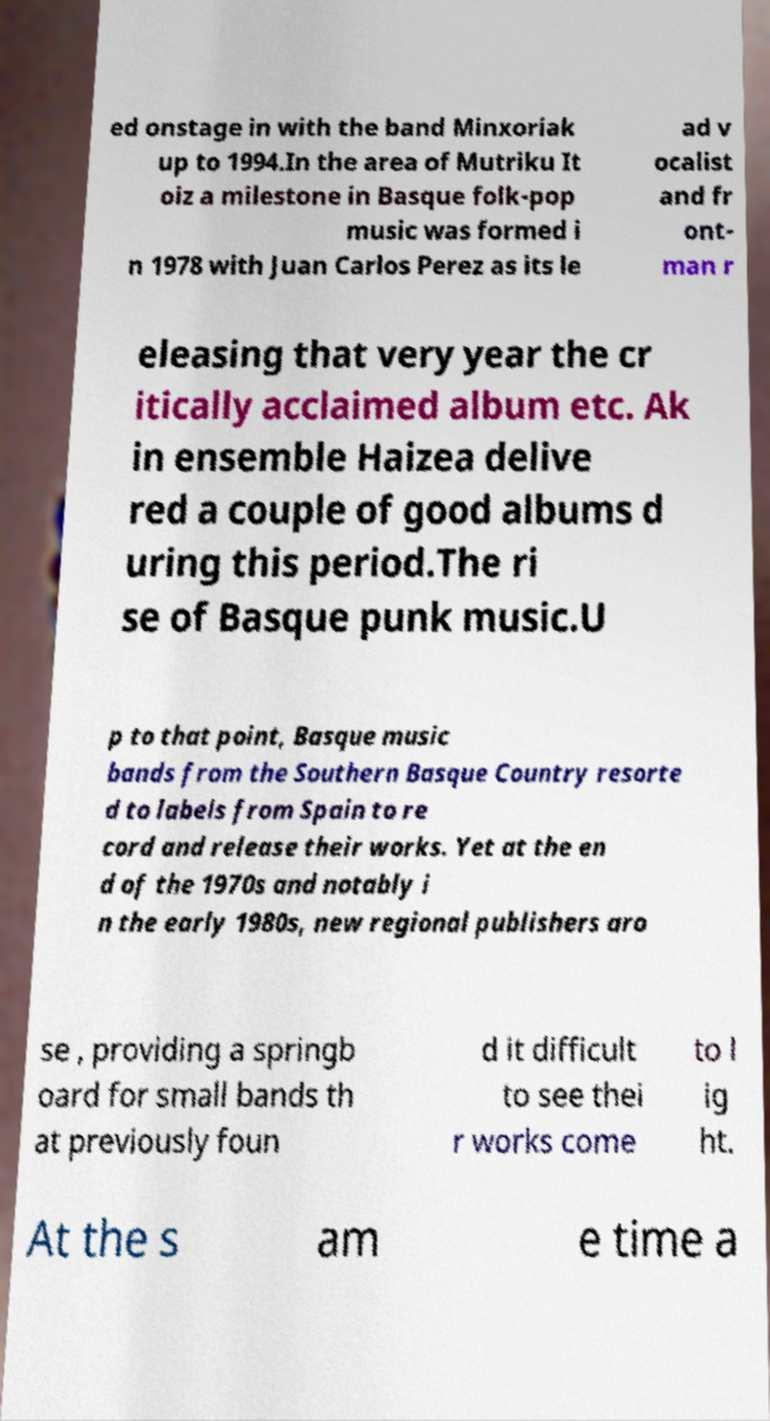Please identify and transcribe the text found in this image. ed onstage in with the band Minxoriak up to 1994.In the area of Mutriku It oiz a milestone in Basque folk-pop music was formed i n 1978 with Juan Carlos Perez as its le ad v ocalist and fr ont- man r eleasing that very year the cr itically acclaimed album etc. Ak in ensemble Haizea delive red a couple of good albums d uring this period.The ri se of Basque punk music.U p to that point, Basque music bands from the Southern Basque Country resorte d to labels from Spain to re cord and release their works. Yet at the en d of the 1970s and notably i n the early 1980s, new regional publishers aro se , providing a springb oard for small bands th at previously foun d it difficult to see thei r works come to l ig ht. At the s am e time a 